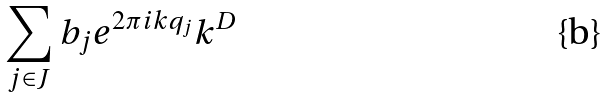Convert formula to latex. <formula><loc_0><loc_0><loc_500><loc_500>\sum _ { j \in J } b _ { j } e ^ { 2 \pi i k q _ { j } } k ^ { D }</formula> 